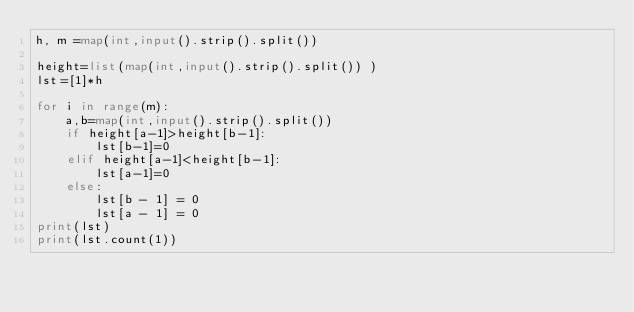Convert code to text. <code><loc_0><loc_0><loc_500><loc_500><_Python_>h, m =map(int,input().strip().split())

height=list(map(int,input().strip().split()) )
lst=[1]*h

for i in range(m):
    a,b=map(int,input().strip().split())
    if height[a-1]>height[b-1]:
        lst[b-1]=0
    elif height[a-1]<height[b-1]:
        lst[a-1]=0
    else:
        lst[b - 1] = 0
        lst[a - 1] = 0
print(lst)
print(lst.count(1))</code> 